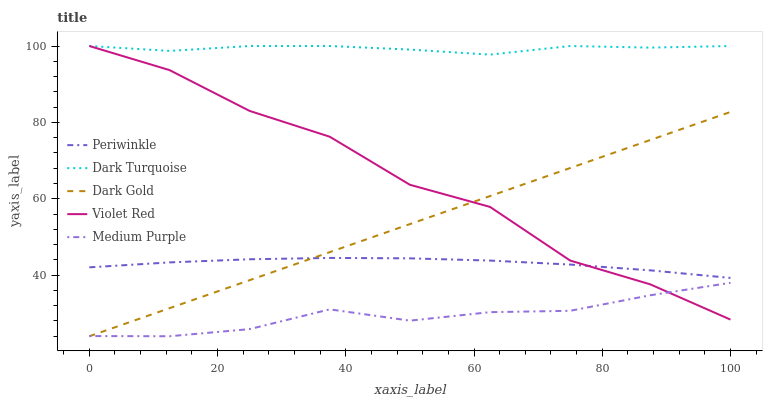Does Medium Purple have the minimum area under the curve?
Answer yes or no. Yes. Does Dark Turquoise have the maximum area under the curve?
Answer yes or no. Yes. Does Violet Red have the minimum area under the curve?
Answer yes or no. No. Does Violet Red have the maximum area under the curve?
Answer yes or no. No. Is Dark Gold the smoothest?
Answer yes or no. Yes. Is Violet Red the roughest?
Answer yes or no. Yes. Is Dark Turquoise the smoothest?
Answer yes or no. No. Is Dark Turquoise the roughest?
Answer yes or no. No. Does Medium Purple have the lowest value?
Answer yes or no. Yes. Does Violet Red have the lowest value?
Answer yes or no. No. Does Violet Red have the highest value?
Answer yes or no. Yes. Does Periwinkle have the highest value?
Answer yes or no. No. Is Medium Purple less than Dark Turquoise?
Answer yes or no. Yes. Is Periwinkle greater than Medium Purple?
Answer yes or no. Yes. Does Dark Gold intersect Violet Red?
Answer yes or no. Yes. Is Dark Gold less than Violet Red?
Answer yes or no. No. Is Dark Gold greater than Violet Red?
Answer yes or no. No. Does Medium Purple intersect Dark Turquoise?
Answer yes or no. No. 